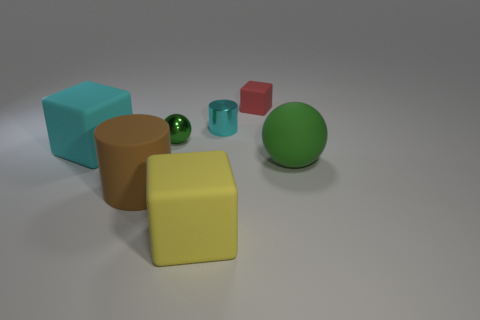Subtract all large rubber blocks. How many blocks are left? 1 Subtract 2 cubes. How many cubes are left? 1 Add 1 cylinders. How many objects exist? 8 Subtract all red blocks. How many blocks are left? 2 Subtract all cubes. How many objects are left? 4 Add 3 large cyan blocks. How many large cyan blocks exist? 4 Subtract 0 purple spheres. How many objects are left? 7 Subtract all brown cylinders. Subtract all yellow balls. How many cylinders are left? 1 Subtract all small red blocks. Subtract all gray cylinders. How many objects are left? 6 Add 4 large matte spheres. How many large matte spheres are left? 5 